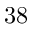<formula> <loc_0><loc_0><loc_500><loc_500>3 8</formula> 